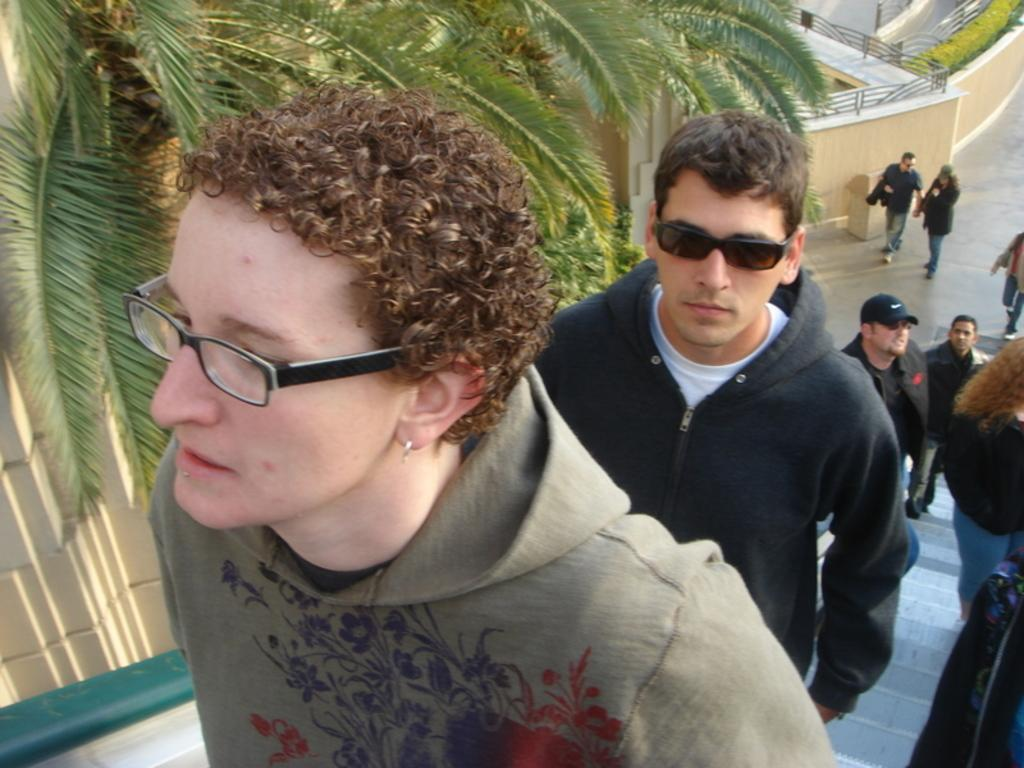What are the people in the image doing? There are people on the stair and people walking on the ground in the image. What can be seen in the background of the image? There are trees, a wall, and plants in the background of the image. What type of mint is growing on the spot where the people are walking in the image? There is no mint or specific spot mentioned in the image; it simply shows people walking on the ground and trees, a wall, and plants in the background. 